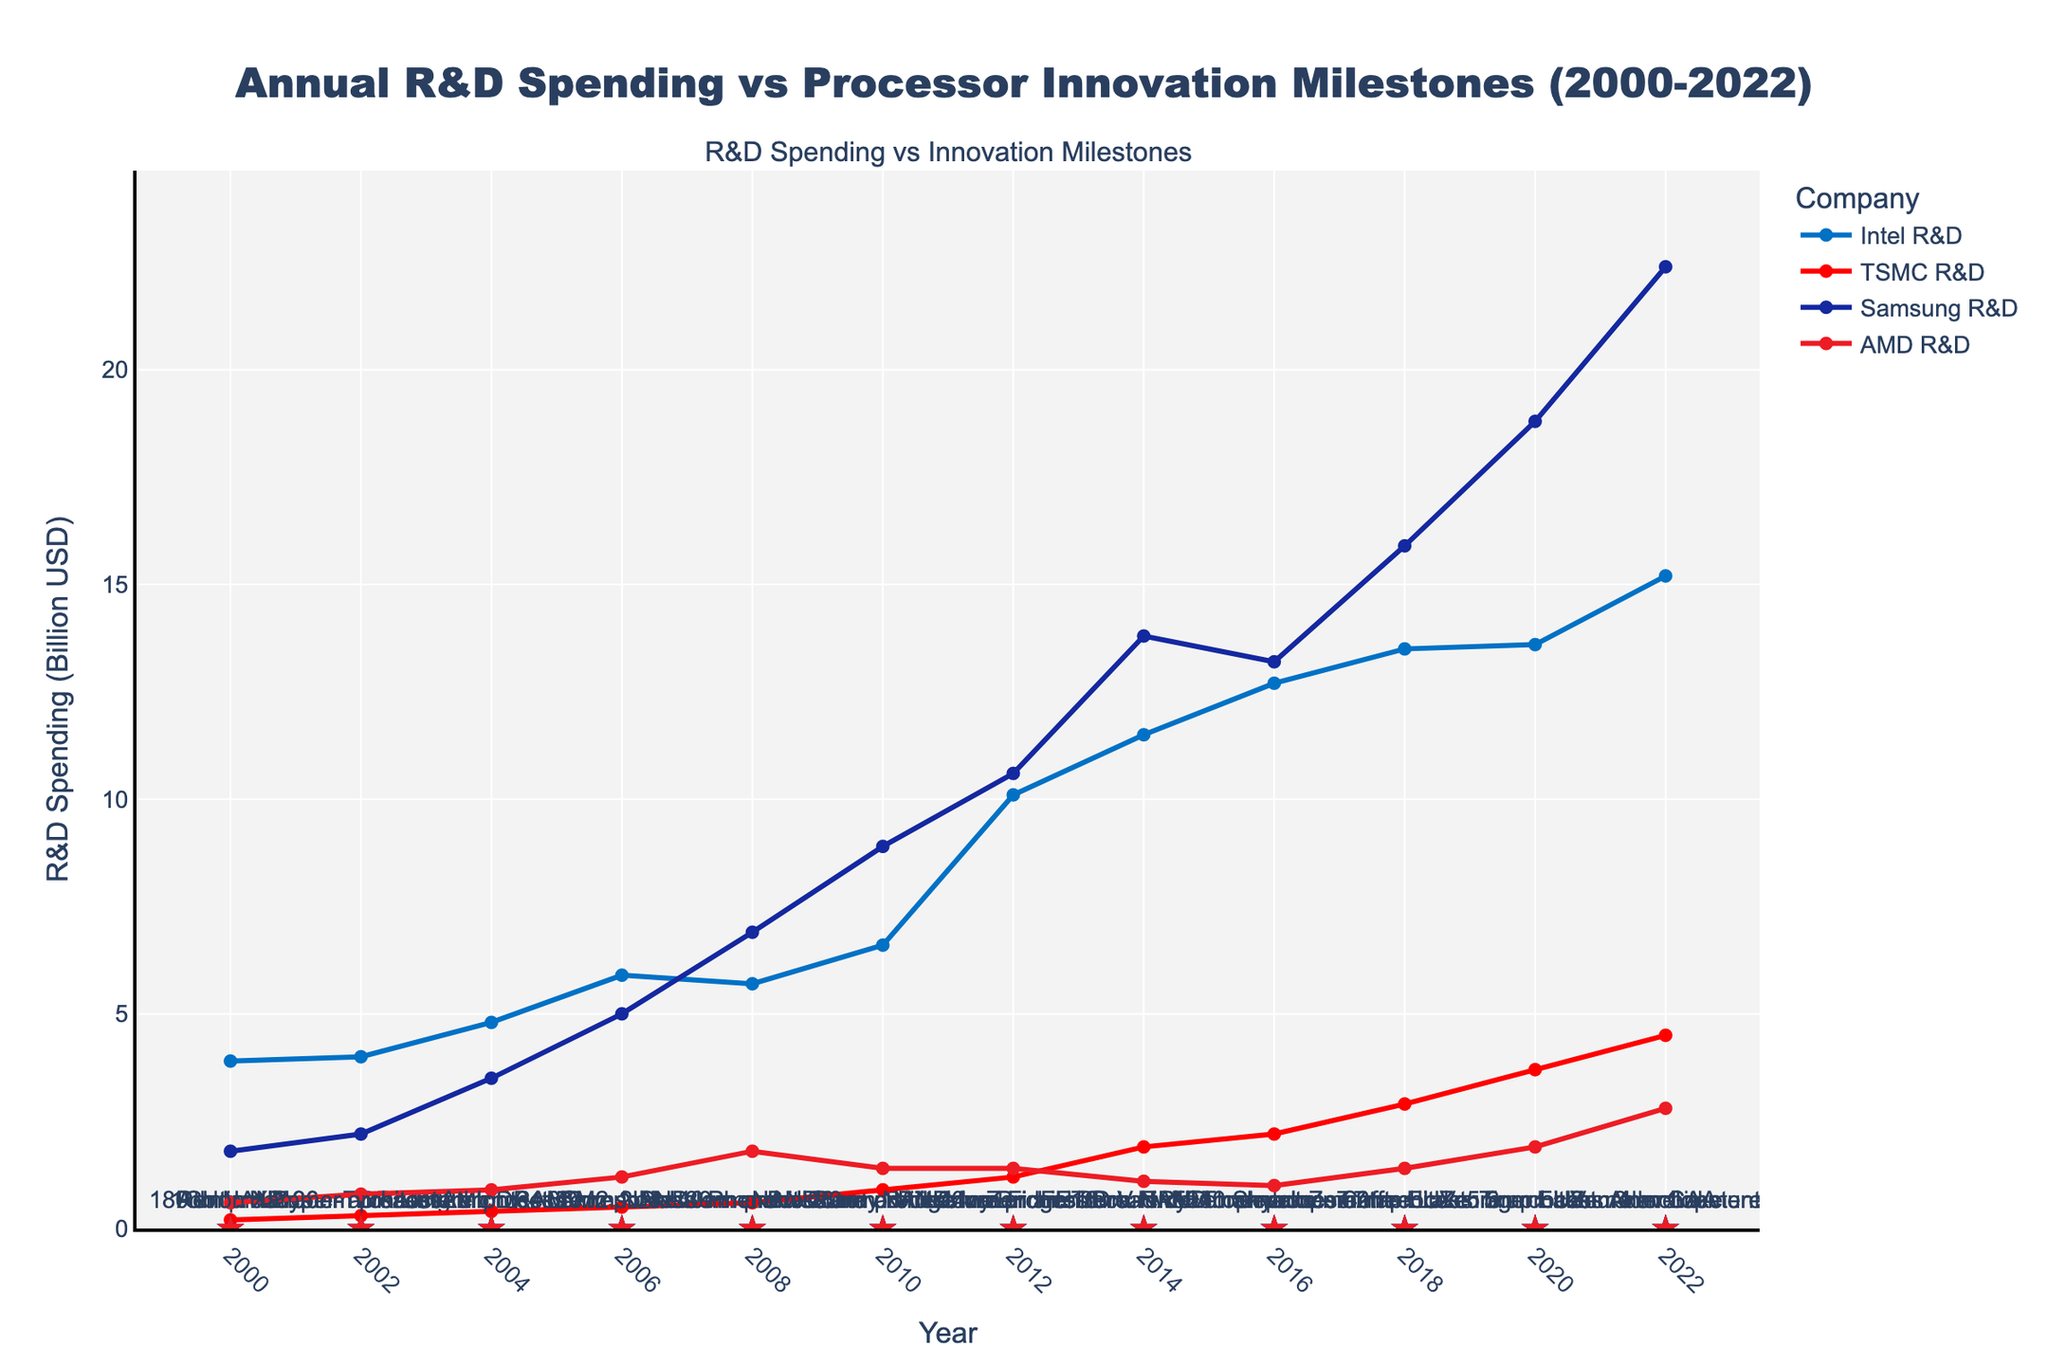Which company had the highest R&D spending in 2022? Look at the data points for the year 2022 and compare the R&D spending values across Intel, TSMC, Samsung, and AMD. TSMC ($4.5B) and Samsung ($22.4B) have the highest values.
Answer: Samsung What is the difference in R&D spending between Intel and AMD in 2018? For 2018, Intel's R&D spending is $13.5B and AMD's is $1.4B. Subtract AMD's value from Intel's: $13.5B - $1.4B = $12.1B.
Answer: $12.1B Which company has constantly increased its R&D spending every year? Examine the trend lines of each company. Samsung's spending rises from $1.8B in 2000 to $22.4B in 2022 showing no decrease in any year.
Answer: Samsung What innovation milestone corresponds with TSMC's initiation of 3nm development? Look at the textual annotations for TSMC and find the one marked '3nm development', which occurs in 2022.
Answer: 2022 Between 2000 and 2022, which company had the most significant single-year increase in R&D spending, and what was the amount? Compare the year-to-year differences for each company. In 2010 to 2012, Intel's spending increases by 10.1 - 6.6 = $3.5B. However, Samsung's increase from 2010 to 2012, 8.9 to 10.6, is smaller. Identify the maximum.
Answer: Intel, $3.5B What is the average R&D spending of AMD from 2000 to 2022? Sum the R&D values for AMD over the years, then divide by the number of years. Sum = (0.6 + 0.8 + 0.9 + 1.2 + 1.8 + 1.4 + 1.4 + 1.1 + 1.0 + 1.4 + 1.9 + 2.8) = 16.3. Number of years = 12. Average = 16.3 / 12 ≈ 1.36.
Answer: $1.36B Which company's R&D spending closely matches the start of AMD's Ryzen announcement in 2016? Check all companies' spending in 2016. AMD announced Ryzen while their R&D was $1.0B. The closest match is TSMC with $2.2B.
Answer: TSMC In which year did Samsung reach an R&D spending milestone correlated with 14nm FinFET innovation? Review innovation milestones linked with Samsung, noting 14nm FinFET innovation. Refer to 2012 R&D.
Answer: 2012 Which company had the second-highest R&D spending in 2014? Examine the R&D spending in 2014 for each company. Intel ($11.5B), TSMC ($1.9B), Samsung ($13.8B), AMD ($1.1B). The second-highest after Samsung is Intel.
Answer: Intel When did Intel introduce the Hyper-Threading innovation, and what was its R&D spending that year? Find Intel's milestone labeled 'Hyper-Threading,' occurring in 2002, alongside an R&D expenditure of $4.0B.
Answer: 2002, $4.0B 